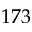Convert formula to latex. <formula><loc_0><loc_0><loc_500><loc_500>1 7 3</formula> 